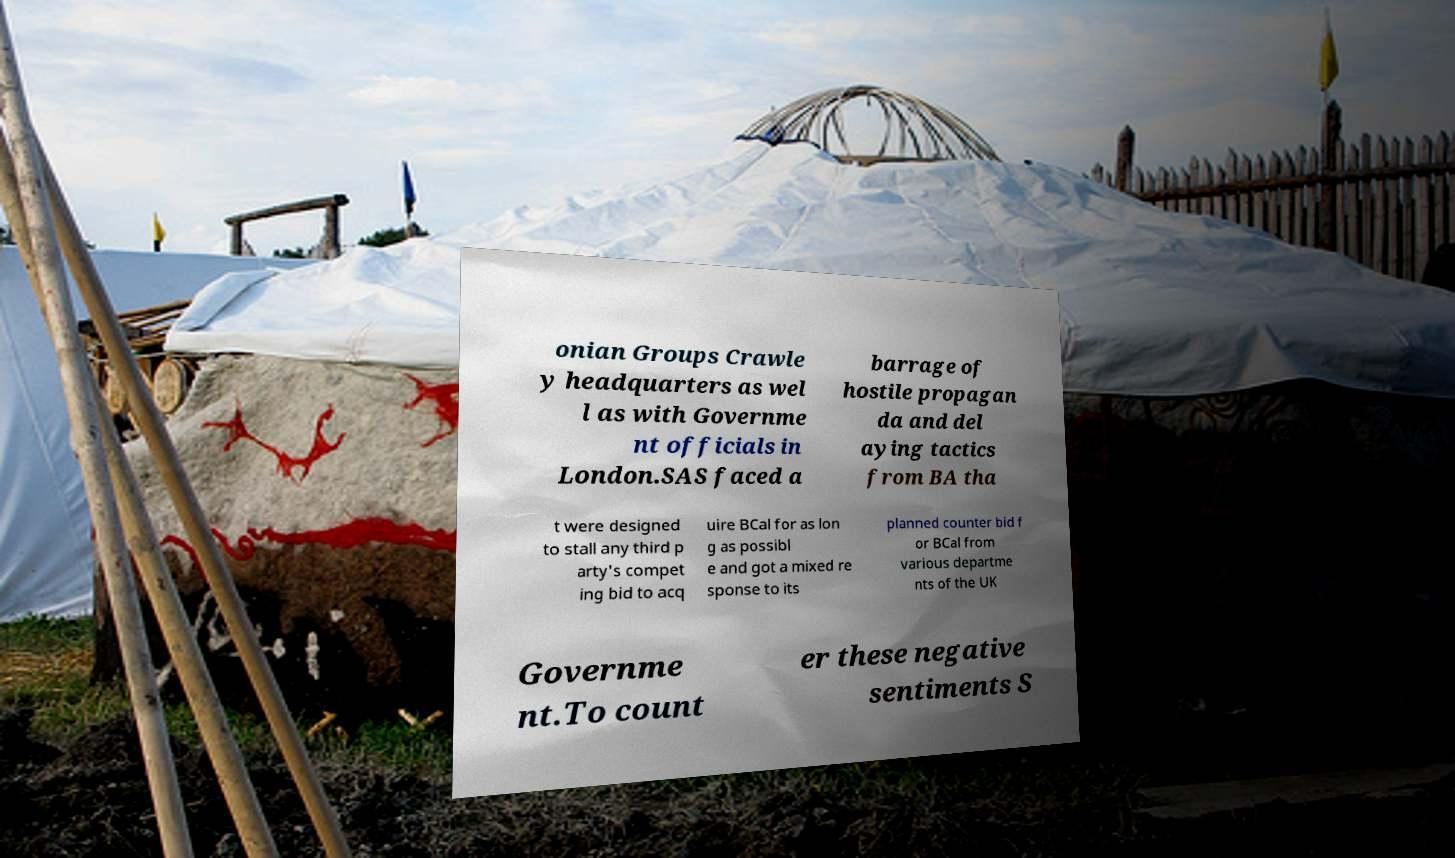There's text embedded in this image that I need extracted. Can you transcribe it verbatim? onian Groups Crawle y headquarters as wel l as with Governme nt officials in London.SAS faced a barrage of hostile propagan da and del aying tactics from BA tha t were designed to stall any third p arty's compet ing bid to acq uire BCal for as lon g as possibl e and got a mixed re sponse to its planned counter bid f or BCal from various departme nts of the UK Governme nt.To count er these negative sentiments S 